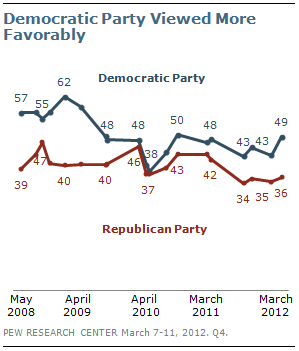Outline some significant characteristics in this image. The Democratic Party and the Republican Party had different values in March 2012. The Republican Party is represented by the red segment. 